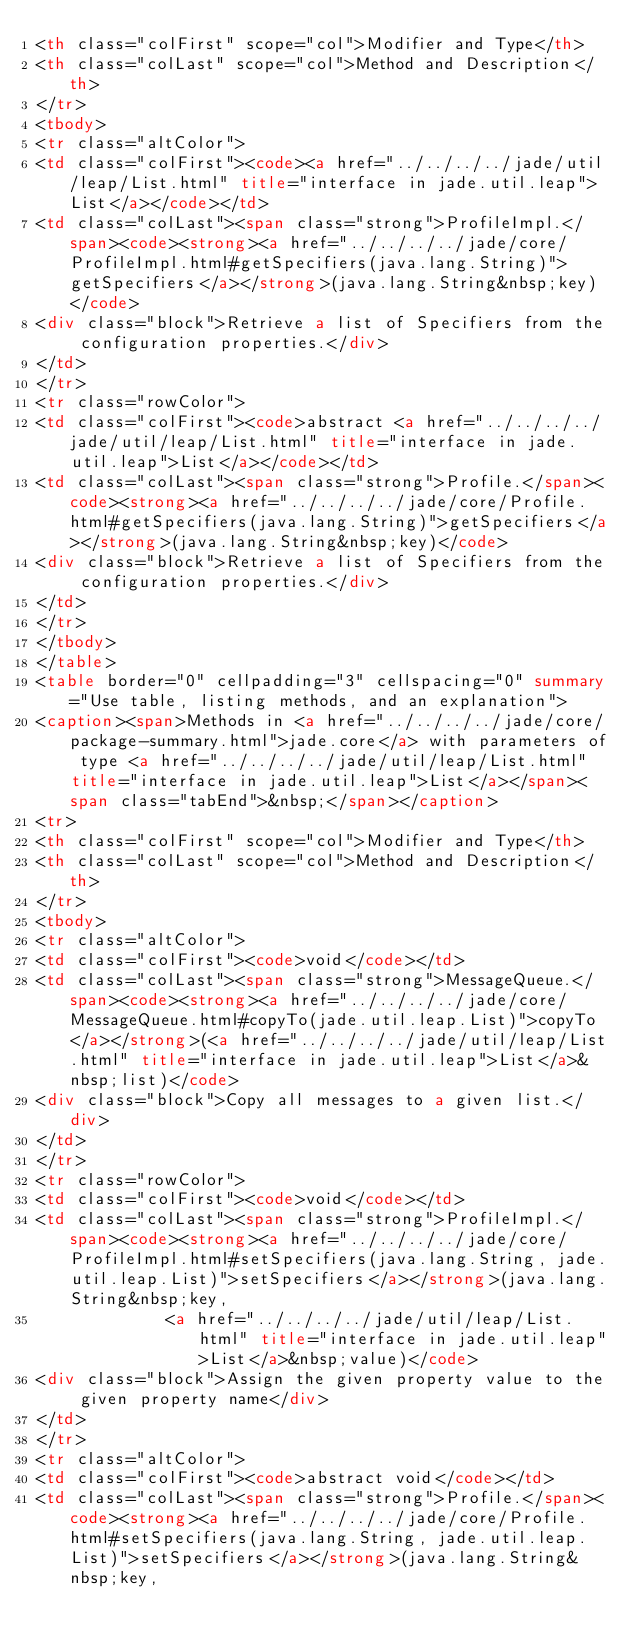Convert code to text. <code><loc_0><loc_0><loc_500><loc_500><_HTML_><th class="colFirst" scope="col">Modifier and Type</th>
<th class="colLast" scope="col">Method and Description</th>
</tr>
<tbody>
<tr class="altColor">
<td class="colFirst"><code><a href="../../../../jade/util/leap/List.html" title="interface in jade.util.leap">List</a></code></td>
<td class="colLast"><span class="strong">ProfileImpl.</span><code><strong><a href="../../../../jade/core/ProfileImpl.html#getSpecifiers(java.lang.String)">getSpecifiers</a></strong>(java.lang.String&nbsp;key)</code>
<div class="block">Retrieve a list of Specifiers from the configuration properties.</div>
</td>
</tr>
<tr class="rowColor">
<td class="colFirst"><code>abstract <a href="../../../../jade/util/leap/List.html" title="interface in jade.util.leap">List</a></code></td>
<td class="colLast"><span class="strong">Profile.</span><code><strong><a href="../../../../jade/core/Profile.html#getSpecifiers(java.lang.String)">getSpecifiers</a></strong>(java.lang.String&nbsp;key)</code>
<div class="block">Retrieve a list of Specifiers from the configuration properties.</div>
</td>
</tr>
</tbody>
</table>
<table border="0" cellpadding="3" cellspacing="0" summary="Use table, listing methods, and an explanation">
<caption><span>Methods in <a href="../../../../jade/core/package-summary.html">jade.core</a> with parameters of type <a href="../../../../jade/util/leap/List.html" title="interface in jade.util.leap">List</a></span><span class="tabEnd">&nbsp;</span></caption>
<tr>
<th class="colFirst" scope="col">Modifier and Type</th>
<th class="colLast" scope="col">Method and Description</th>
</tr>
<tbody>
<tr class="altColor">
<td class="colFirst"><code>void</code></td>
<td class="colLast"><span class="strong">MessageQueue.</span><code><strong><a href="../../../../jade/core/MessageQueue.html#copyTo(jade.util.leap.List)">copyTo</a></strong>(<a href="../../../../jade/util/leap/List.html" title="interface in jade.util.leap">List</a>&nbsp;list)</code>
<div class="block">Copy all messages to a given list.</div>
</td>
</tr>
<tr class="rowColor">
<td class="colFirst"><code>void</code></td>
<td class="colLast"><span class="strong">ProfileImpl.</span><code><strong><a href="../../../../jade/core/ProfileImpl.html#setSpecifiers(java.lang.String, jade.util.leap.List)">setSpecifiers</a></strong>(java.lang.String&nbsp;key,
             <a href="../../../../jade/util/leap/List.html" title="interface in jade.util.leap">List</a>&nbsp;value)</code>
<div class="block">Assign the given property value to the given property name</div>
</td>
</tr>
<tr class="altColor">
<td class="colFirst"><code>abstract void</code></td>
<td class="colLast"><span class="strong">Profile.</span><code><strong><a href="../../../../jade/core/Profile.html#setSpecifiers(java.lang.String, jade.util.leap.List)">setSpecifiers</a></strong>(java.lang.String&nbsp;key,</code> 